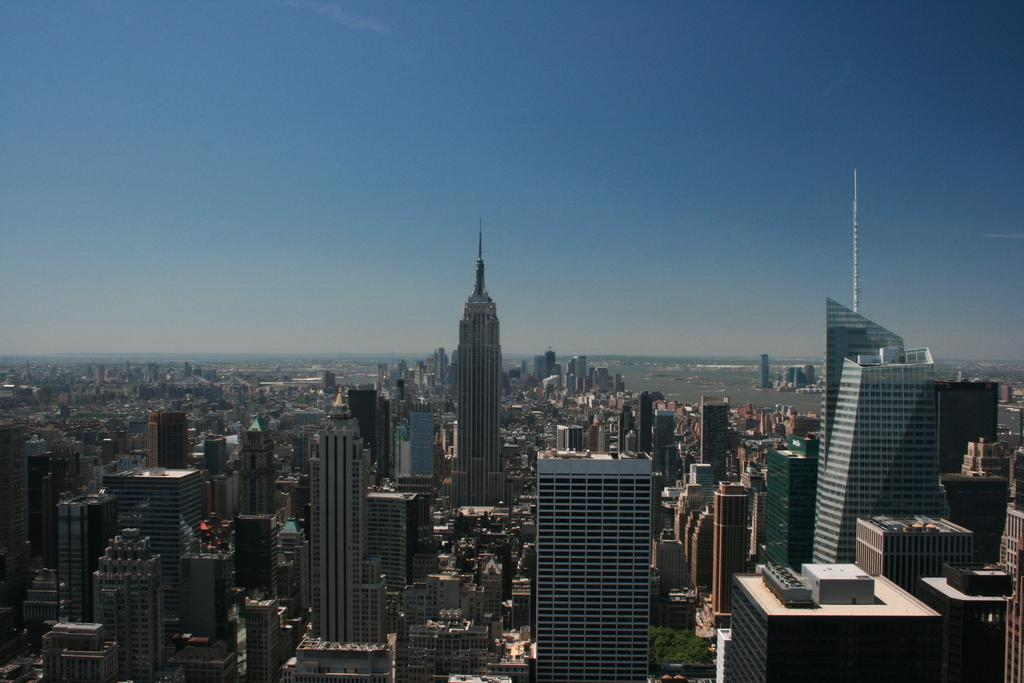What structures are located at the bottom of the image? There are buildings and skyscrapers at the bottom of the image. What else can be seen at the bottom of the image? There are trees at the bottom of the image. What is visible at the top of the image? The sky is visible at the top of the image. What type of cherry is being used to paint the sky in the image? There is no cherry or painting activity present in the image. How many pancakes are stacked on top of the trees in the image? There are no pancakes present in the image; it features buildings, skyscrapers, and trees. 